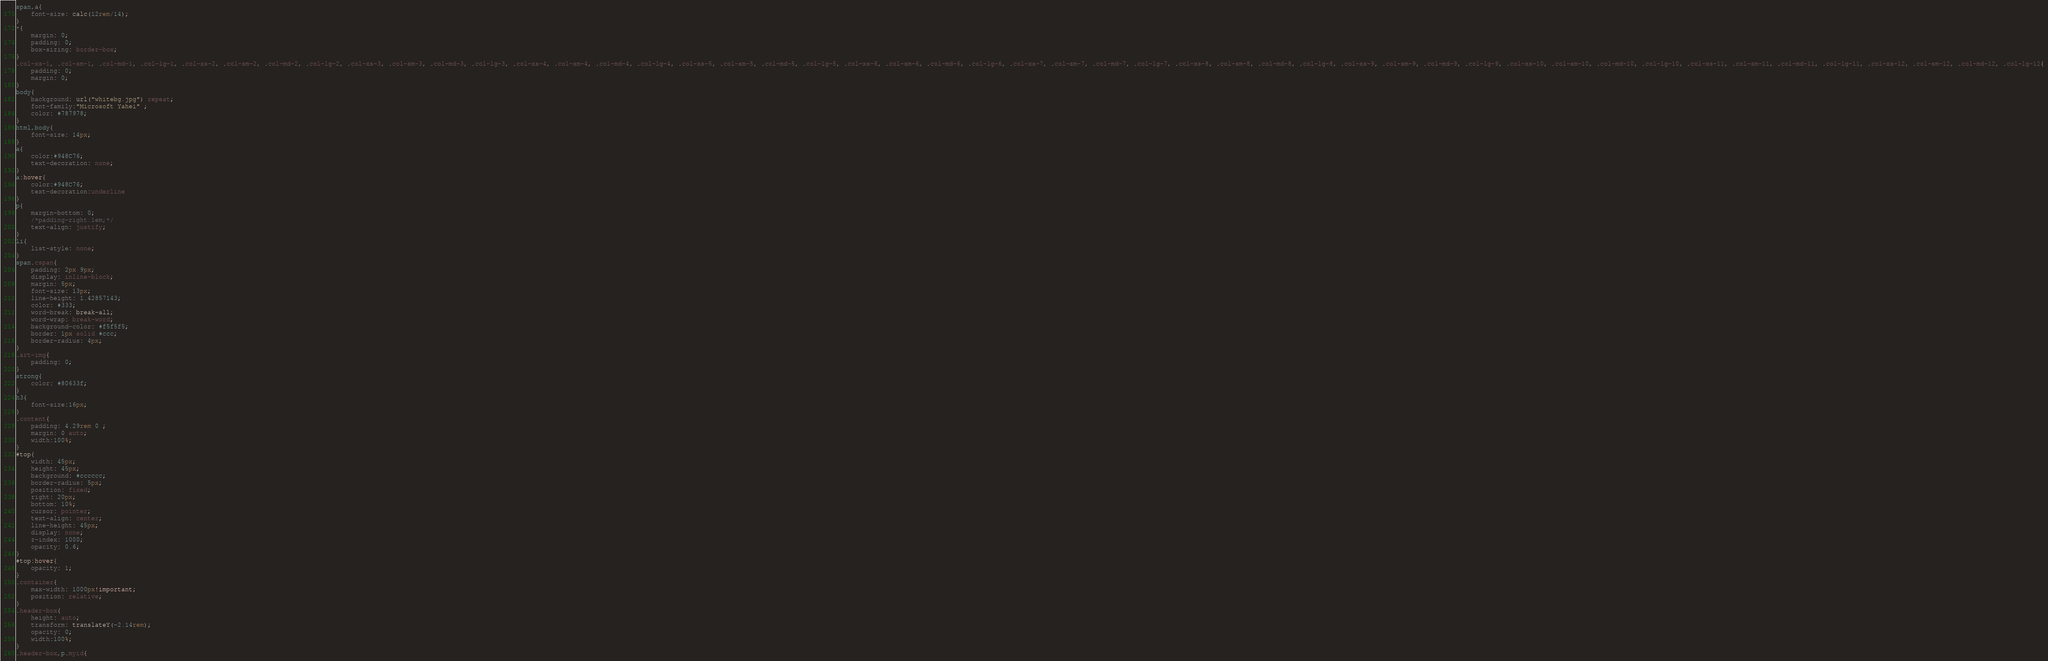Convert code to text. <code><loc_0><loc_0><loc_500><loc_500><_CSS_>span,a{
    font-size: calc(12rem/14);
}
*{
    margin: 0;
    padding: 0;
    box-sizing: border-box;
}
.col-xs-1, .col-sm-1, .col-md-1, .col-lg-1, .col-xs-2, .col-sm-2, .col-md-2, .col-lg-2, .col-xs-3, .col-sm-3, .col-md-3, .col-lg-3, .col-xs-4, .col-sm-4, .col-md-4, .col-lg-4, .col-xs-5, .col-sm-5, .col-md-5, .col-lg-5, .col-xs-6, .col-sm-6, .col-md-6, .col-lg-6, .col-xs-7, .col-sm-7, .col-md-7, .col-lg-7, .col-xs-8, .col-sm-8, .col-md-8, .col-lg-8, .col-xs-9, .col-sm-9, .col-md-9, .col-lg-9, .col-xs-10, .col-sm-10, .col-md-10, .col-lg-10, .col-xs-11, .col-sm-11, .col-md-11, .col-lg-11, .col-xs-12, .col-sm-12, .col-md-12, .col-lg-12{
    padding: 0;
    margin: 0;
}
body{
    background: url("whitebg.jpg") repeat;
    font-family:"Microsoft Yahei" ;
    color: #787978;
}
html,body{
    font-size: 14px;
}
a{
    color:#948C76;
    text-decoration: none;
}
a:hover{
    color:#948C76;
    text-decoration:underline
}
p{
    margin-bottom: 0;
    /*padding-right:1em;*/
    text-align: justify;
}
li{
    list-style: none;
}
span.cspan{
    padding: 2px 9px;
    display: inline-block;
    margin: 5px;
    font-size: 13px;
    line-height: 1.42857143;
    color: #333;
    word-break: break-all;
    word-wrap: break-word;
    background-color: #f5f5f5;
    border: 1px solid #ccc;
    border-radius: 4px;
}
.art-img{
    padding: 0;
}
strong{
    color: #80633f;
}
h3{
    font-size:16px;
}
.content{
    padding: 4.29rem 0 ;
    margin: 0 auto;
    width:100%;
}
#top{
    width: 45px;
    height: 45px;
    background: #cccccc;
    border-radius: 5px;
    position: fixed;
    right: 20px;
    bottom: 10%;
    cursor: pointer;
    text-align: center;
    line-height: 45px;
    display: none;
    z-index: 1000;
    opacity: 0.6;
}
#top:hover{
    opacity: 1;
}
.container{
    max-width: 1000px!important;
    position: relative;
}
.header-box{
    height: auto;
    transform: translateY(-2.14rem);
    opacity: 0;
    width:100%;
}
.header-box,p.myid{</code> 